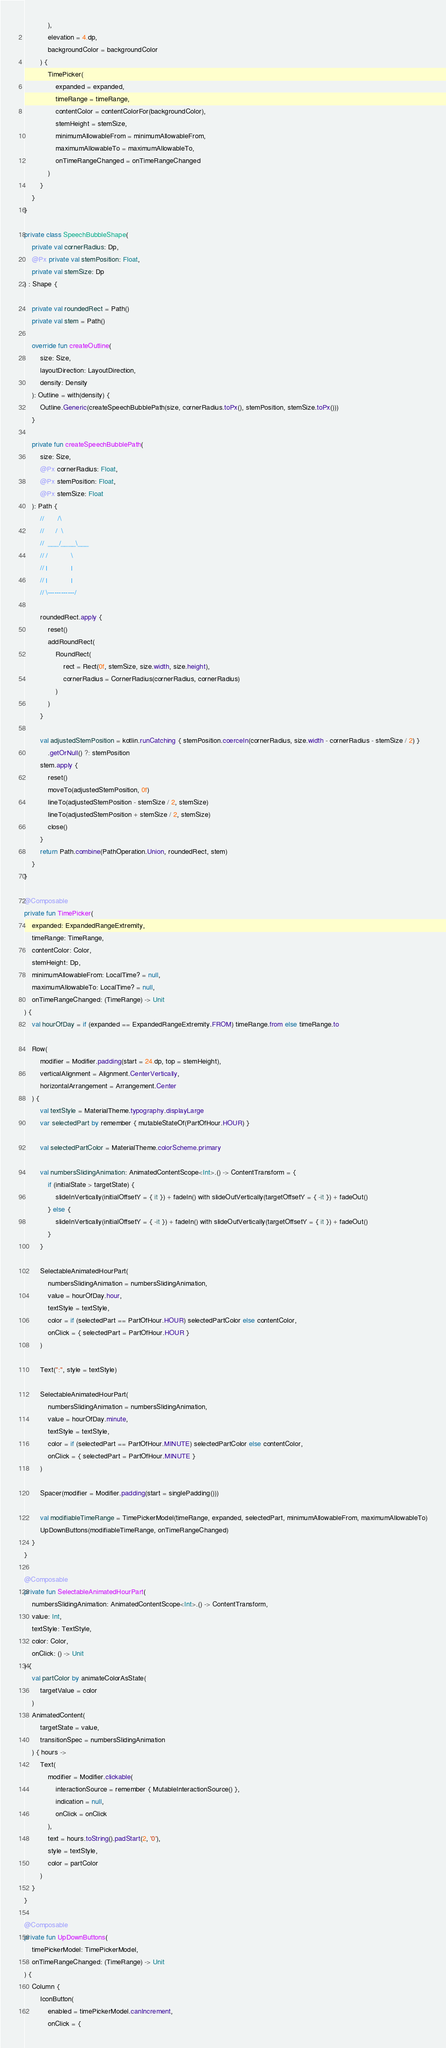Convert code to text. <code><loc_0><loc_0><loc_500><loc_500><_Kotlin_>            ),
            elevation = 4.dp,
            backgroundColor = backgroundColor
        ) {
            TimePicker(
                expanded = expanded,
                timeRange = timeRange,
                contentColor = contentColorFor(backgroundColor),
                stemHeight = stemSize,
                minimumAllowableFrom = minimumAllowableFrom,
                maximumAllowableTo = maximumAllowableTo,
                onTimeRangeChanged = onTimeRangeChanged
            )
        }
    }
}

private class SpeechBubbleShape(
    private val cornerRadius: Dp,
    @Px private val stemPosition: Float,
    private val stemSize: Dp
) : Shape {

    private val roundedRect = Path()
    private val stem = Path()

    override fun createOutline(
        size: Size,
        layoutDirection: LayoutDirection,
        density: Density
    ): Outline = with(density) {
        Outline.Generic(createSpeechBubblePath(size, cornerRadius.toPx(), stemPosition, stemSize.toPx()))
    }

    private fun createSpeechBubblePath(
        size: Size,
        @Px cornerRadius: Float,
        @Px stemPosition: Float,
        @Px stemSize: Float
    ): Path {
        //       /\
        //      /  \
        //  ___/____\___
        // /            \
        // |            |
        // |            |
        // \------------/

        roundedRect.apply {
            reset()
            addRoundRect(
                RoundRect(
                    rect = Rect(0f, stemSize, size.width, size.height),
                    cornerRadius = CornerRadius(cornerRadius, cornerRadius)
                )
            )
        }

        val adjustedStemPosition = kotlin.runCatching { stemPosition.coerceIn(cornerRadius, size.width - cornerRadius - stemSize / 2) }
            .getOrNull() ?: stemPosition
        stem.apply {
            reset()
            moveTo(adjustedStemPosition, 0f)
            lineTo(adjustedStemPosition - stemSize / 2, stemSize)
            lineTo(adjustedStemPosition + stemSize / 2, stemSize)
            close()
        }
        return Path.combine(PathOperation.Union, roundedRect, stem)
    }
}

@Composable
private fun TimePicker(
    expanded: ExpandedRangeExtremity,
    timeRange: TimeRange,
    contentColor: Color,
    stemHeight: Dp,
    minimumAllowableFrom: LocalTime? = null,
    maximumAllowableTo: LocalTime? = null,
    onTimeRangeChanged: (TimeRange) -> Unit
) {
    val hourOfDay = if (expanded == ExpandedRangeExtremity.FROM) timeRange.from else timeRange.to

    Row(
        modifier = Modifier.padding(start = 24.dp, top = stemHeight),
        verticalAlignment = Alignment.CenterVertically,
        horizontalArrangement = Arrangement.Center
    ) {
        val textStyle = MaterialTheme.typography.displayLarge
        var selectedPart by remember { mutableStateOf(PartOfHour.HOUR) }

        val selectedPartColor = MaterialTheme.colorScheme.primary

        val numbersSlidingAnimation: AnimatedContentScope<Int>.() -> ContentTransform = {
            if (initialState > targetState) {
                slideInVertically(initialOffsetY = { it }) + fadeIn() with slideOutVertically(targetOffsetY = { -it }) + fadeOut()
            } else {
                slideInVertically(initialOffsetY = { -it }) + fadeIn() with slideOutVertically(targetOffsetY = { it }) + fadeOut()
            }
        }

        SelectableAnimatedHourPart(
            numbersSlidingAnimation = numbersSlidingAnimation,
            value = hourOfDay.hour,
            textStyle = textStyle,
            color = if (selectedPart == PartOfHour.HOUR) selectedPartColor else contentColor,
            onClick = { selectedPart = PartOfHour.HOUR }
        )

        Text(":", style = textStyle)

        SelectableAnimatedHourPart(
            numbersSlidingAnimation = numbersSlidingAnimation,
            value = hourOfDay.minute,
            textStyle = textStyle,
            color = if (selectedPart == PartOfHour.MINUTE) selectedPartColor else contentColor,
            onClick = { selectedPart = PartOfHour.MINUTE }
        )

        Spacer(modifier = Modifier.padding(start = singlePadding()))

        val modifiableTimeRange = TimePickerModel(timeRange, expanded, selectedPart, minimumAllowableFrom, maximumAllowableTo)
        UpDownButtons(modifiableTimeRange, onTimeRangeChanged)
    }
}

@Composable
private fun SelectableAnimatedHourPart(
    numbersSlidingAnimation: AnimatedContentScope<Int>.() -> ContentTransform,
    value: Int,
    textStyle: TextStyle,
    color: Color,
    onClick: () -> Unit
) {
    val partColor by animateColorAsState(
        targetValue = color
    )
    AnimatedContent(
        targetState = value,
        transitionSpec = numbersSlidingAnimation
    ) { hours ->
        Text(
            modifier = Modifier.clickable(
                interactionSource = remember { MutableInteractionSource() },
                indication = null,
                onClick = onClick
            ),
            text = hours.toString().padStart(2, '0'),
            style = textStyle,
            color = partColor
        )
    }
}

@Composable
private fun UpDownButtons(
    timePickerModel: TimePickerModel,
    onTimeRangeChanged: (TimeRange) -> Unit
) {
    Column {
        IconButton(
            enabled = timePickerModel.canIncrement,
            onClick = {</code> 